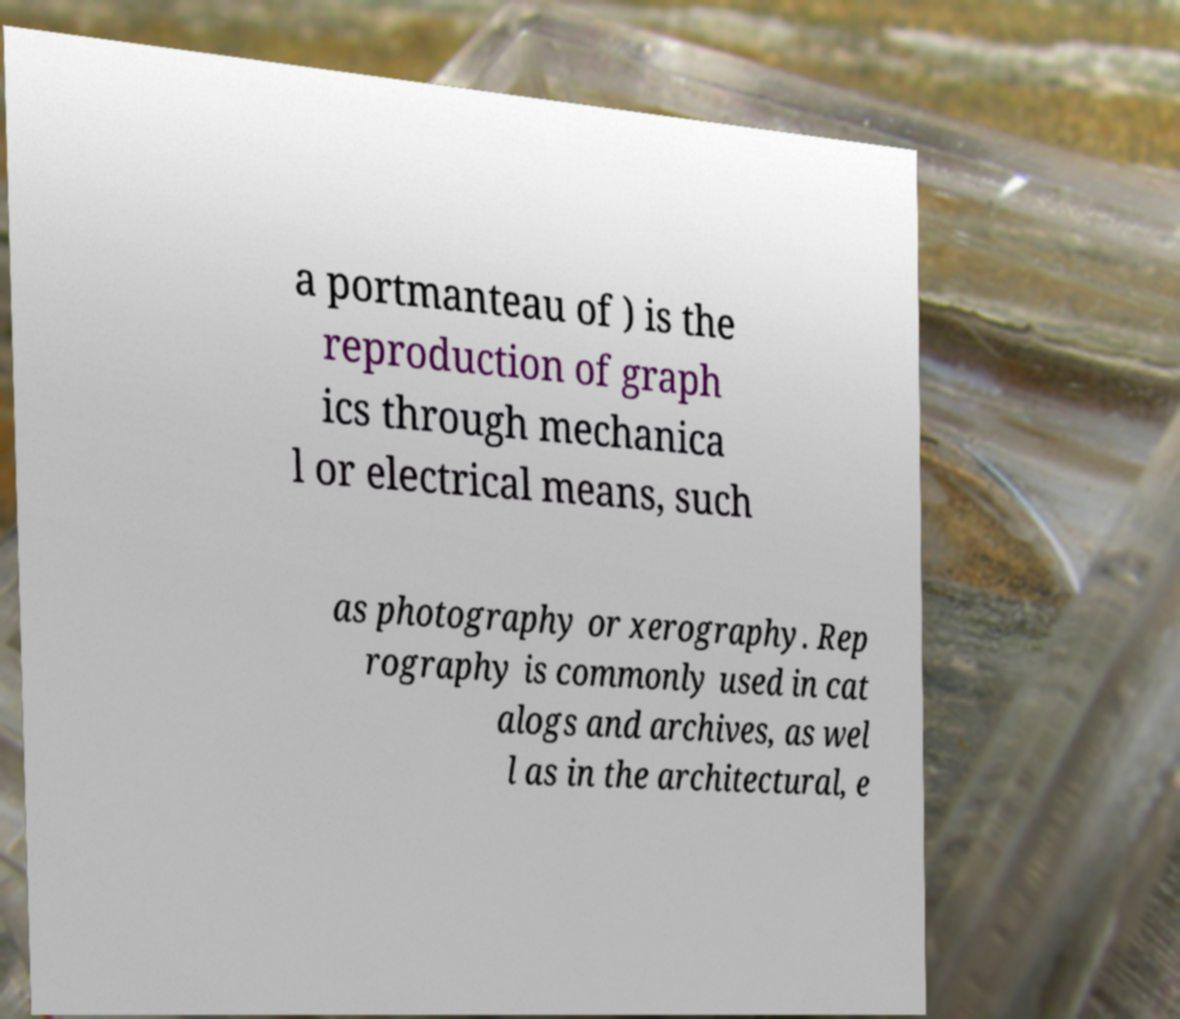Can you accurately transcribe the text from the provided image for me? a portmanteau of ) is the reproduction of graph ics through mechanica l or electrical means, such as photography or xerography. Rep rography is commonly used in cat alogs and archives, as wel l as in the architectural, e 